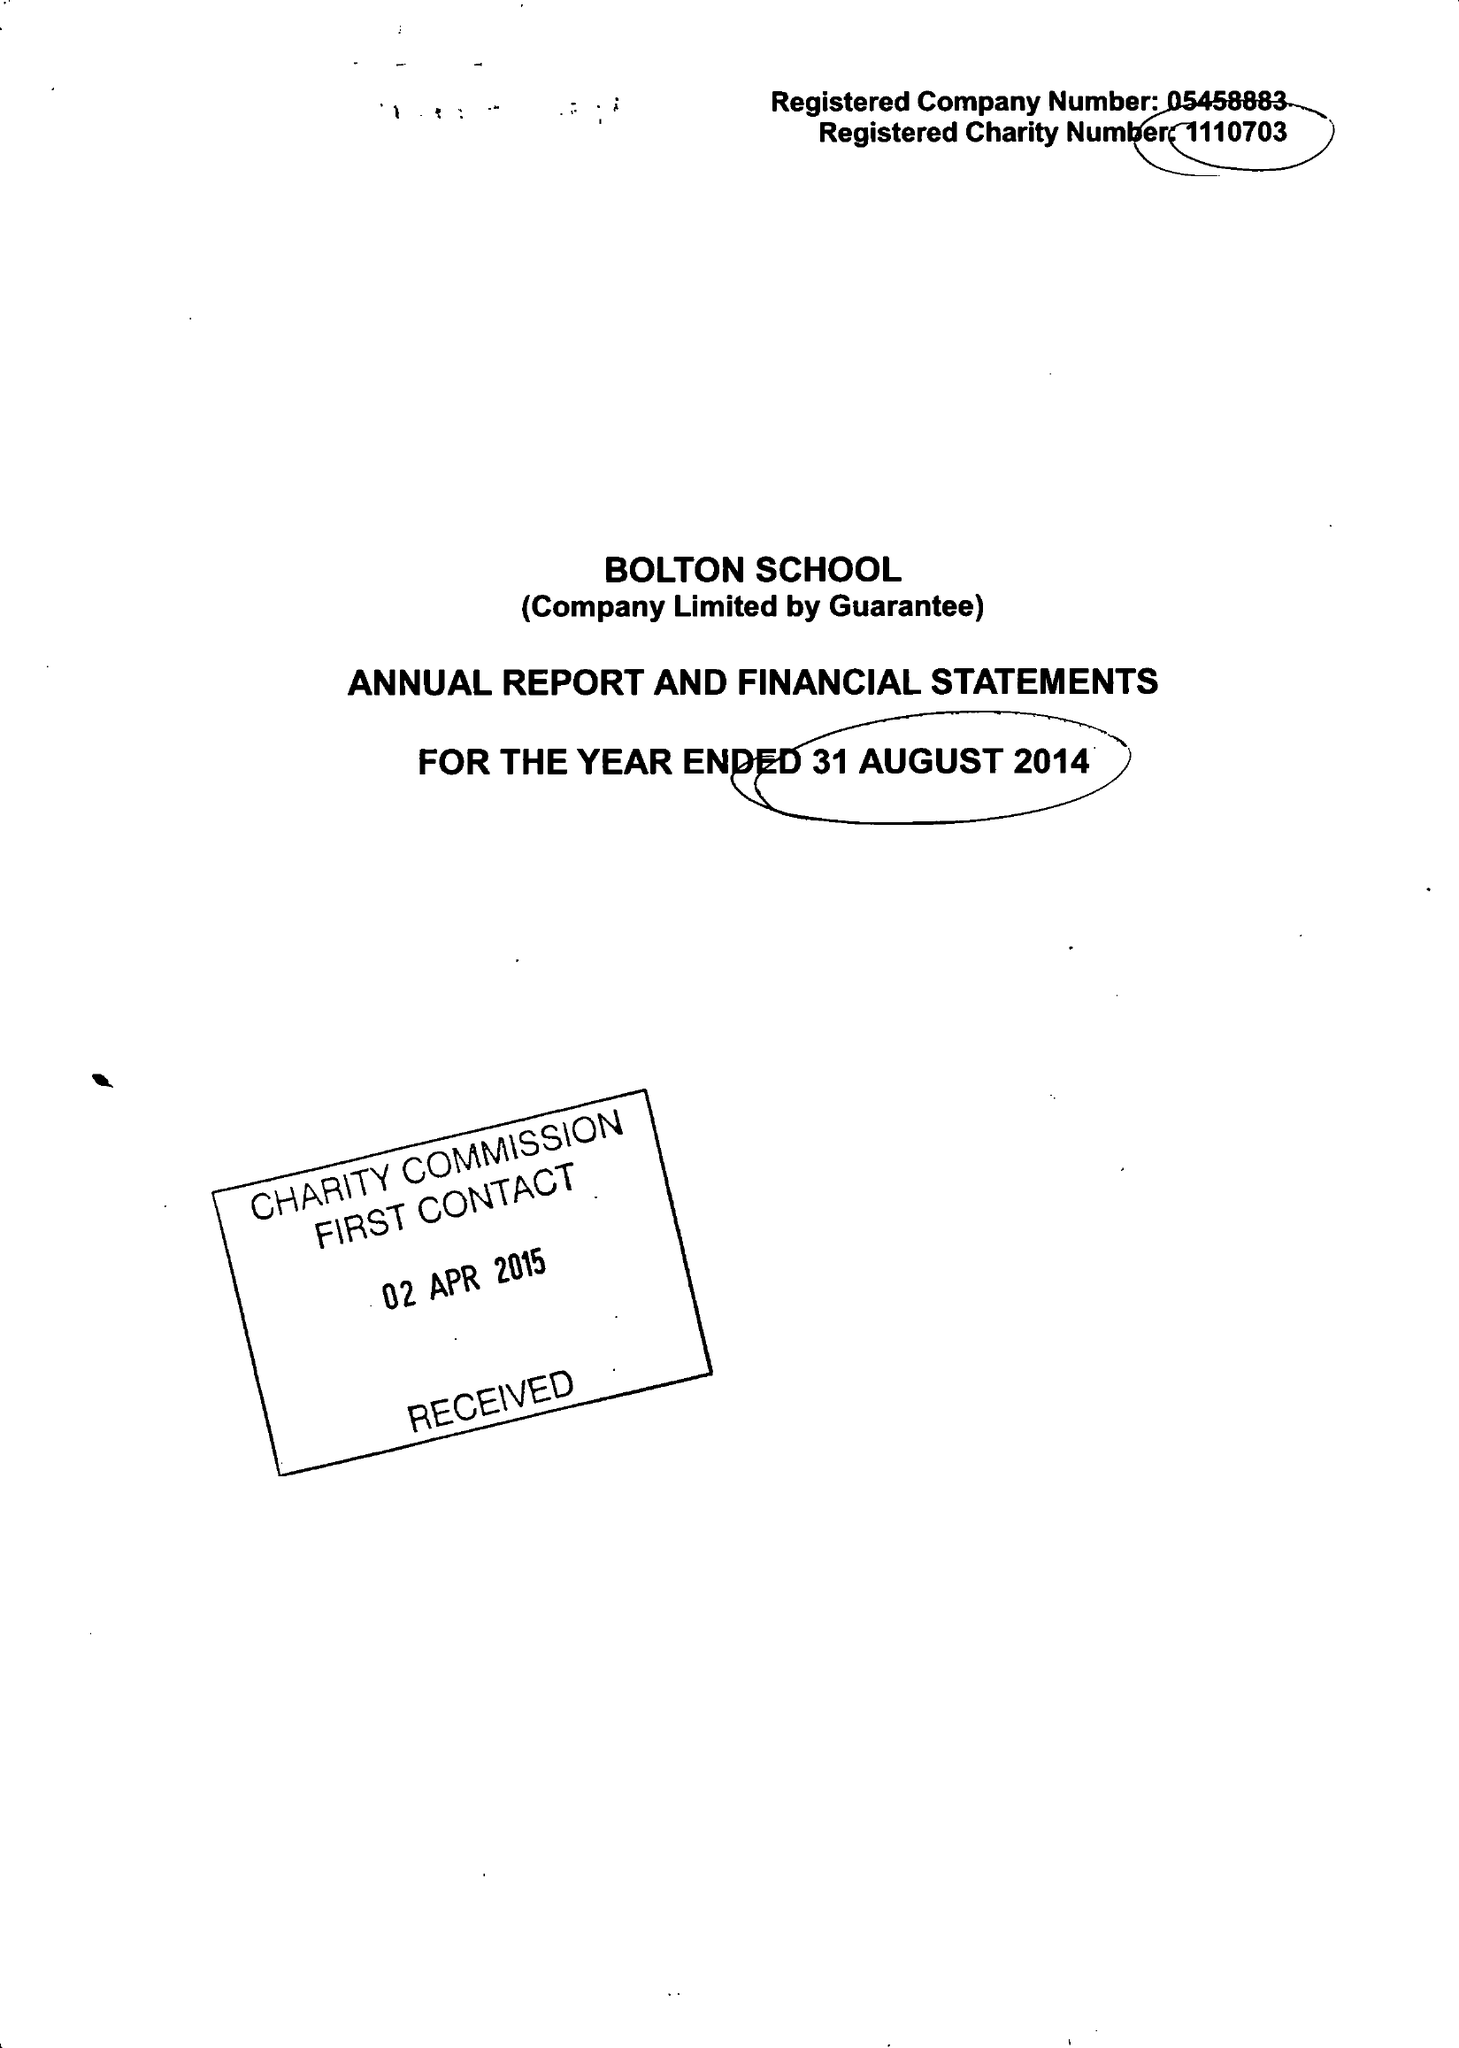What is the value for the charity_name?
Answer the question using a single word or phrase. Bolton School Ltd. 